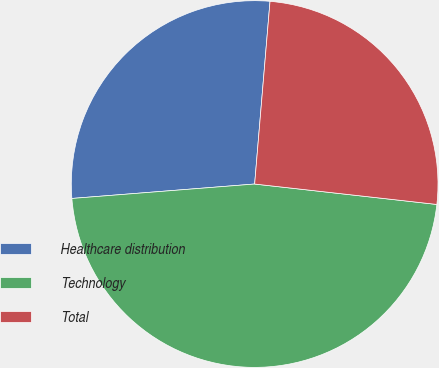Convert chart. <chart><loc_0><loc_0><loc_500><loc_500><pie_chart><fcel>Healthcare distribution<fcel>Technology<fcel>Total<nl><fcel>27.59%<fcel>46.97%<fcel>25.44%<nl></chart> 